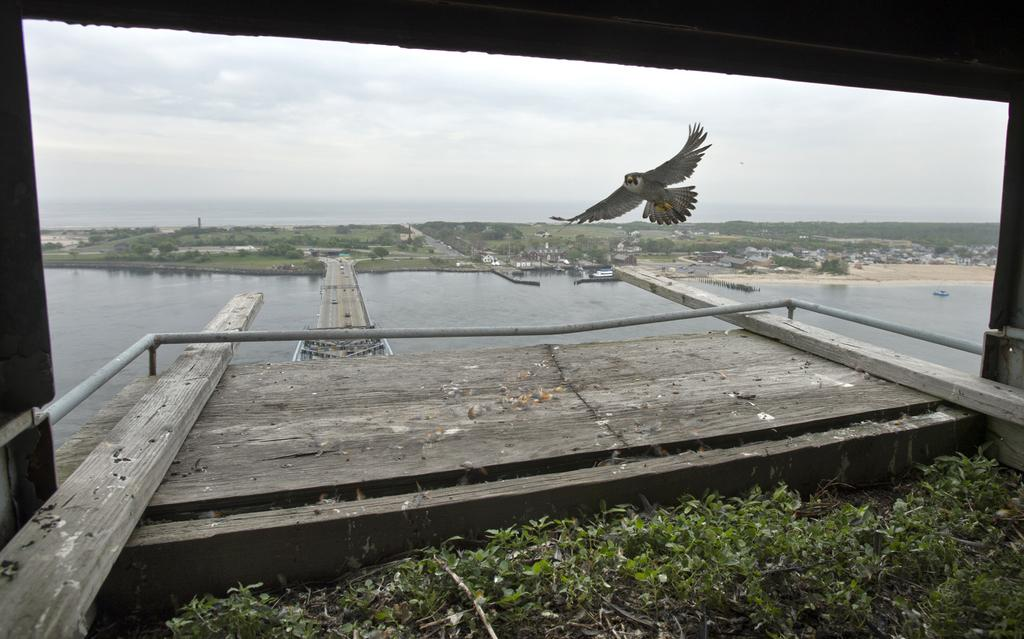What is the bird doing in the image? The bird is flying in the image. What type of structure can be seen in the image? There is a bridge in the image. What else can be seen in the image besides the bridge? There are buildings, trees, and a boat on the water in the image. What is the condition of the sky in the image? The sky is cloudy in the image. Can you see a giraffe walking on the bridge in the image? No, there is no giraffe present in the image. How does the coach balance itself on the boat in the image? There is no coach present in the image, and the boat does not have a coach on it. 